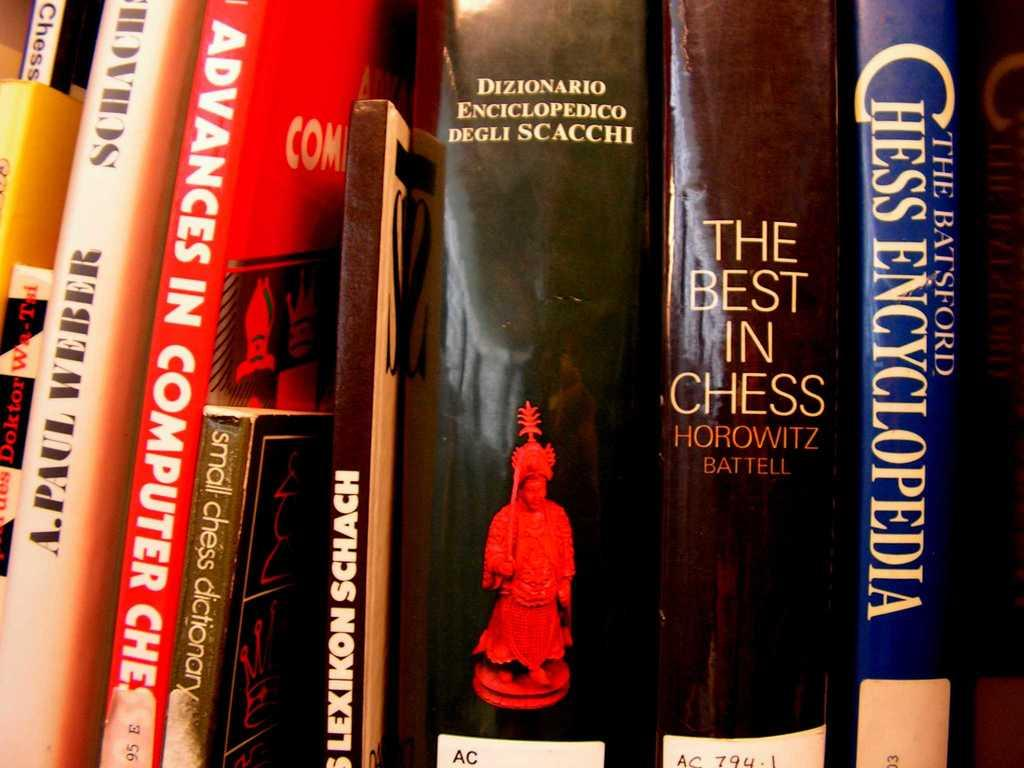<image>
Relay a brief, clear account of the picture shown. A group of Chess related books such as The Best In Chess and The Batsford Chess Encyclopedia. 